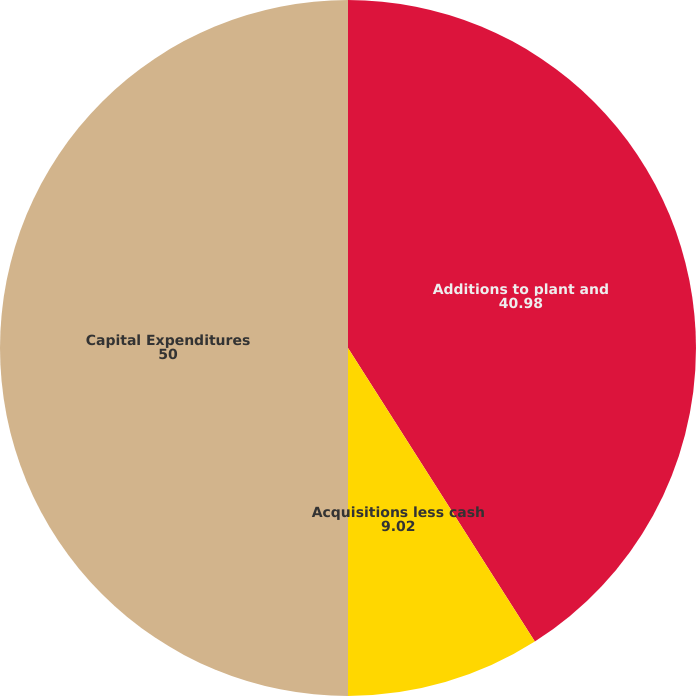<chart> <loc_0><loc_0><loc_500><loc_500><pie_chart><fcel>Additions to plant and<fcel>Acquisitions less cash<fcel>Capital Expenditures<nl><fcel>40.98%<fcel>9.02%<fcel>50.0%<nl></chart> 